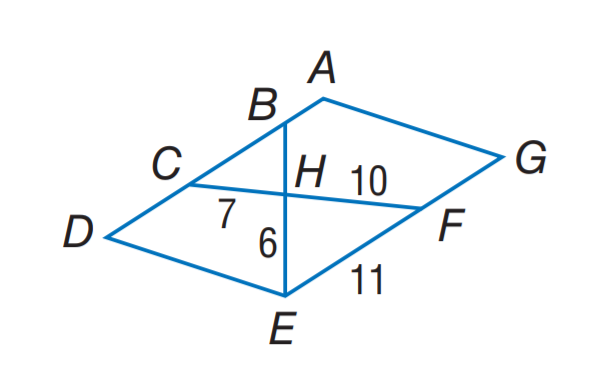Question: Find the perimeter of the \triangle C B H, if \triangle C B H \sim \triangle F E H, A D E G is a parallelogram, C H = 7, F H = 10, F E = 11, and E H = 6. Rounded to the nearest tenth.
Choices:
A. 10.6
B. 17.6
C. 18.9
D. 20.3
Answer with the letter. Answer: C 